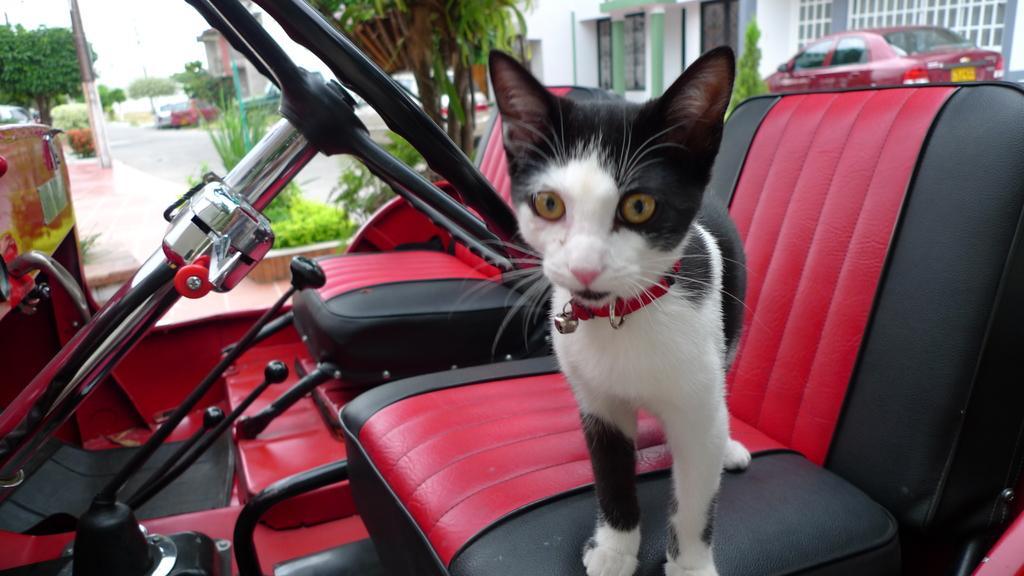Describe this image in one or two sentences. In this image i can see a cat in a vehicle. In the background i can see few trees, a road, few other vehicles and a building. 